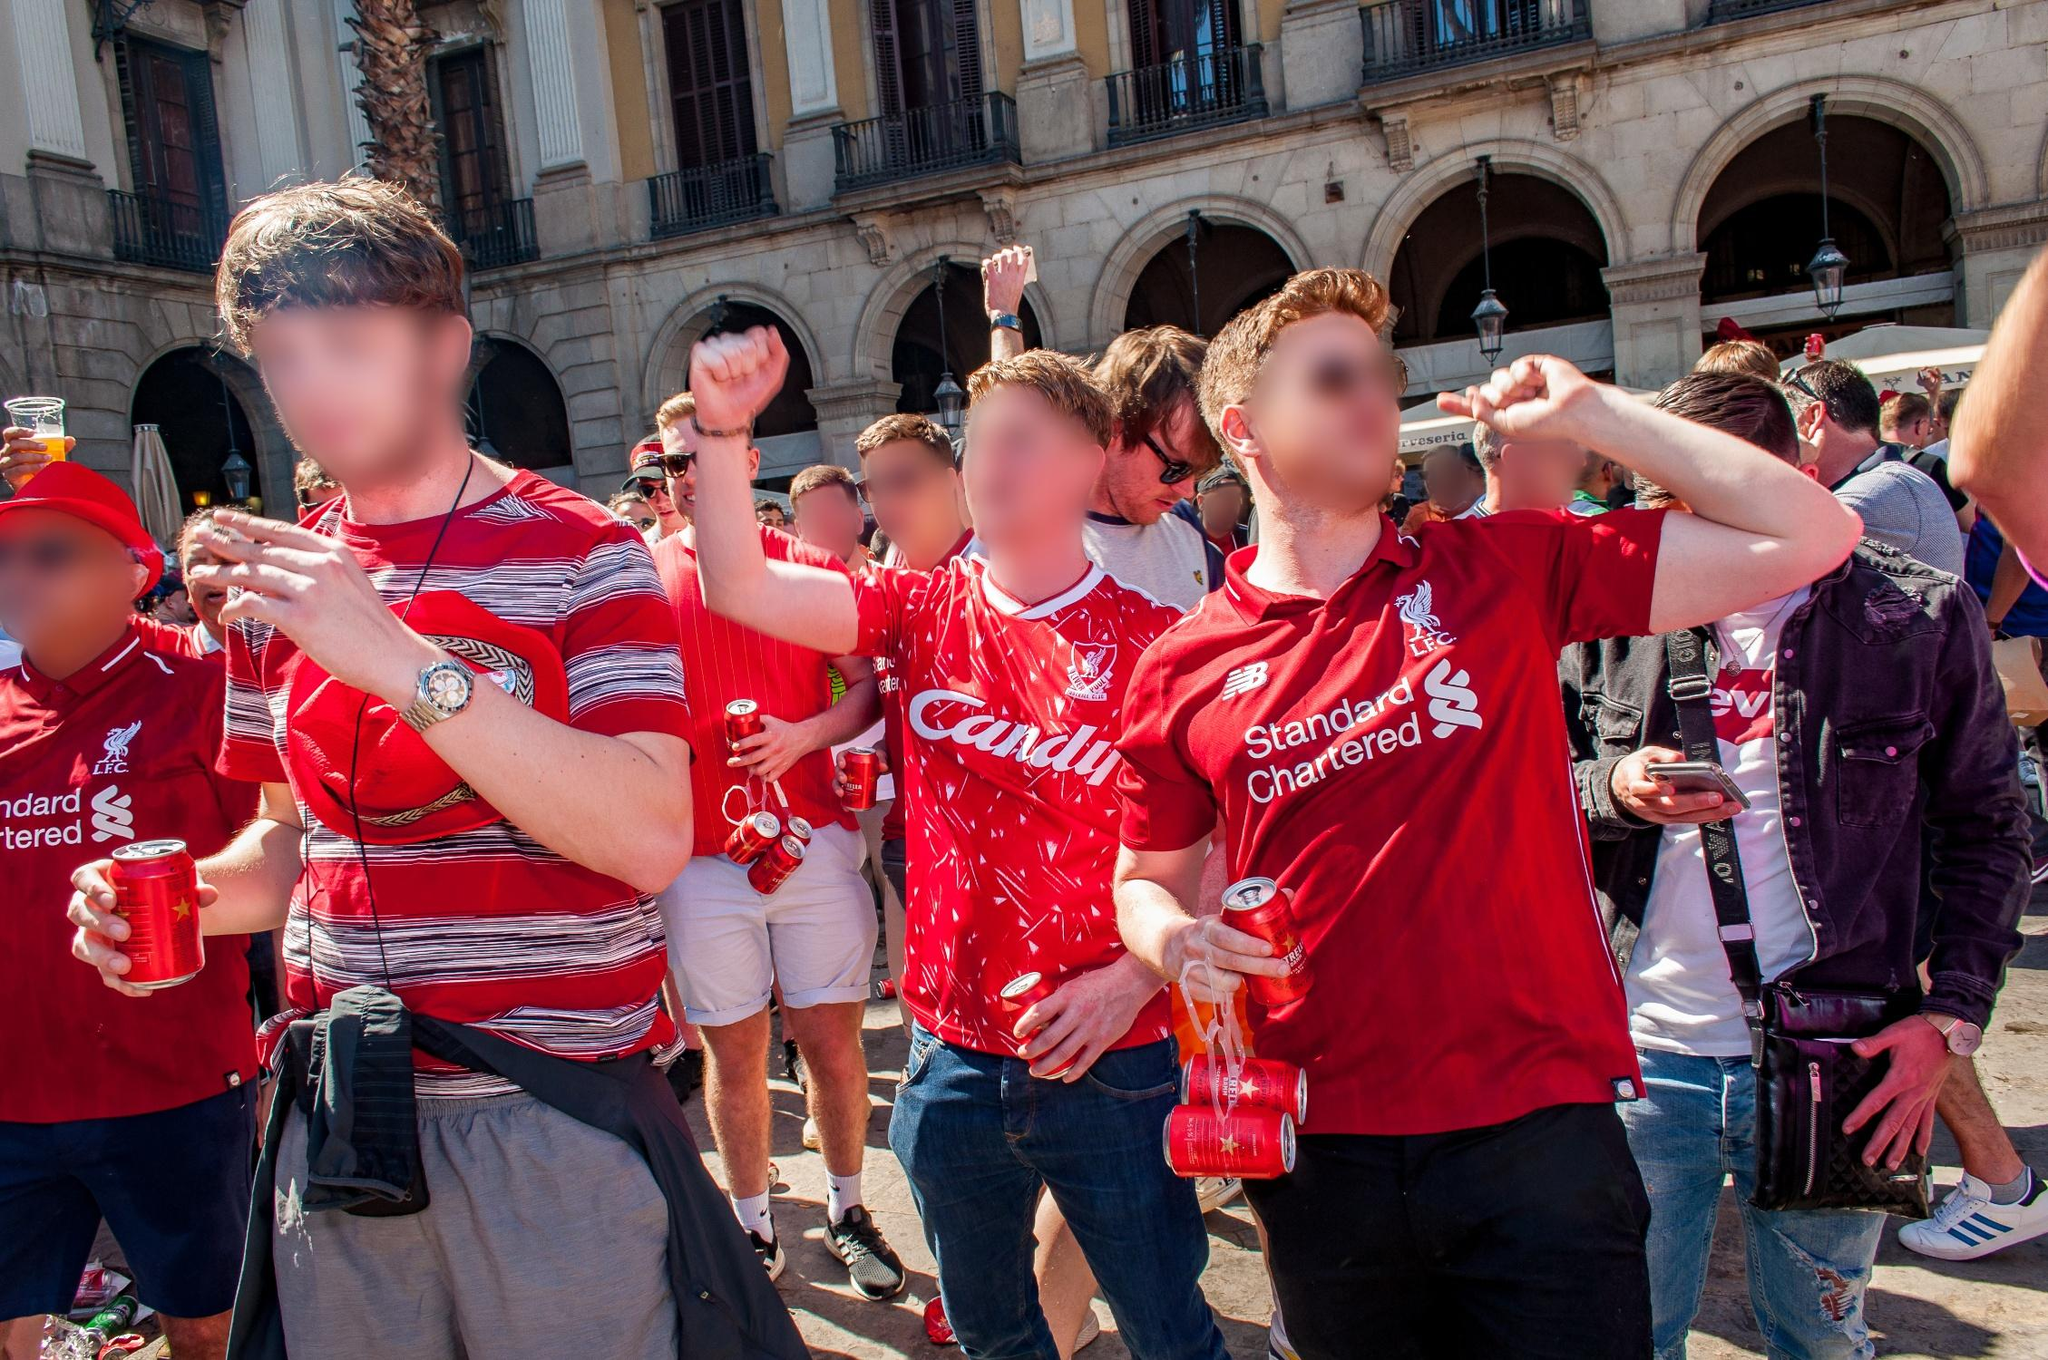What is this photo about? The image captures a spirited scene in front of a historic European-style building characterized by grand arches and columns. The daylight highlights the architectural details, as a group of people in matching red shirts congregate at the foreground. These individuals are evidently supporters or members of a club, given their attire showcasing logos and designs, such as 'Candil' and 'Standard Chartered'. They seem to be partaking in a celebration, holding drinks in plastic cups and cans, and expressing joy and excitement. The vibrant red of their shirts sharply contrasts with the more muted tones of the building, enriching the lively atmosphere. The photograph is taken from a low angle, which not only emphasizes the architecture's grandeur but also enhances the dynamic and jubilant mood of the gathering. While the landmark 'sa_15165' is not specified, the collective enthusiasm and architectural setting suggest a moment of celebration, possibly related to a sporting event or cultural festivity. 